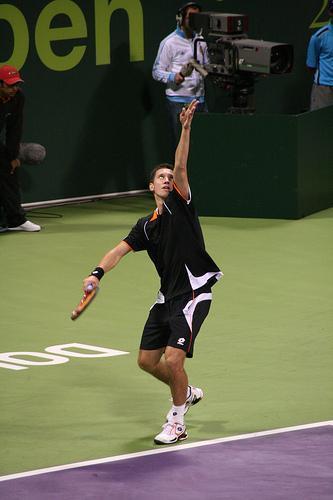How many tennis players are in the image?
Give a very brief answer. 1. 